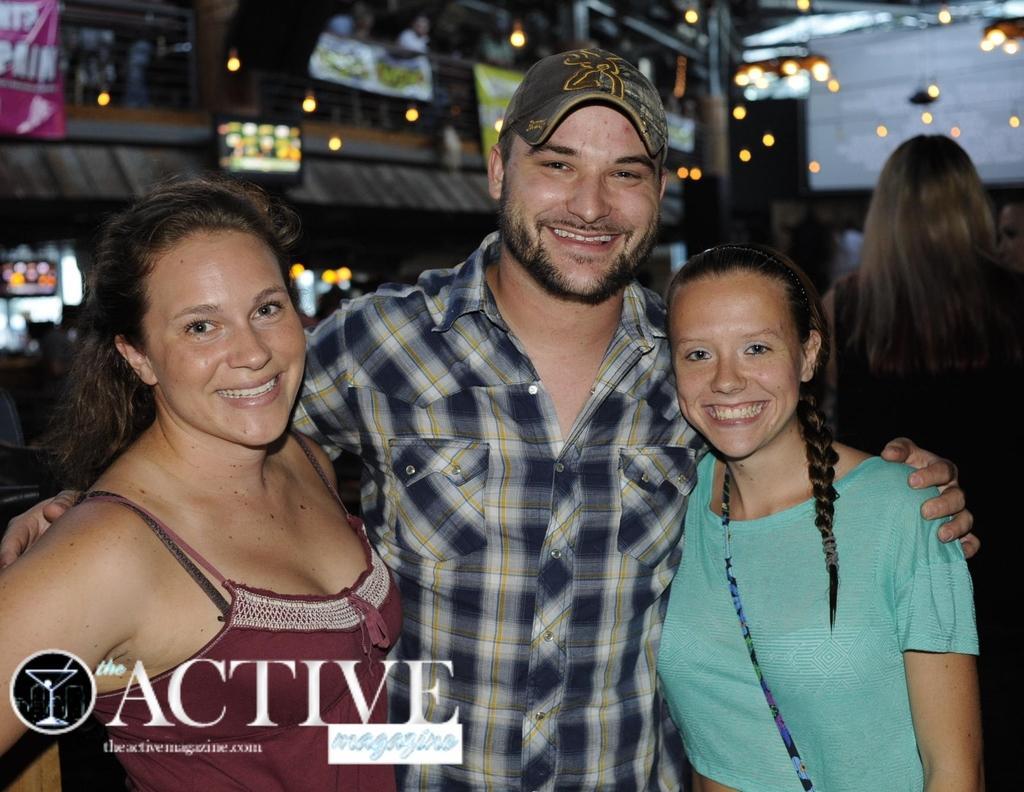Could you give a brief overview of what you see in this image? In this picture there is a man in the middle and inside there are two girls smiling and giving pose into the camera. Behind there is a TV screens and hanging light on the ceiling. In the front bottom side of the image we can see a watermark quote on which "Activity" is written. 